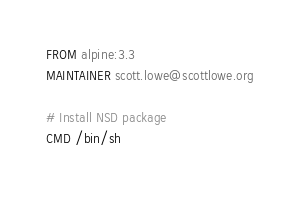<code> <loc_0><loc_0><loc_500><loc_500><_Dockerfile_>FROM alpine:3.3
MAINTAINER scott.lowe@scottlowe.org

# Install NSD package
CMD /bin/sh

</code> 